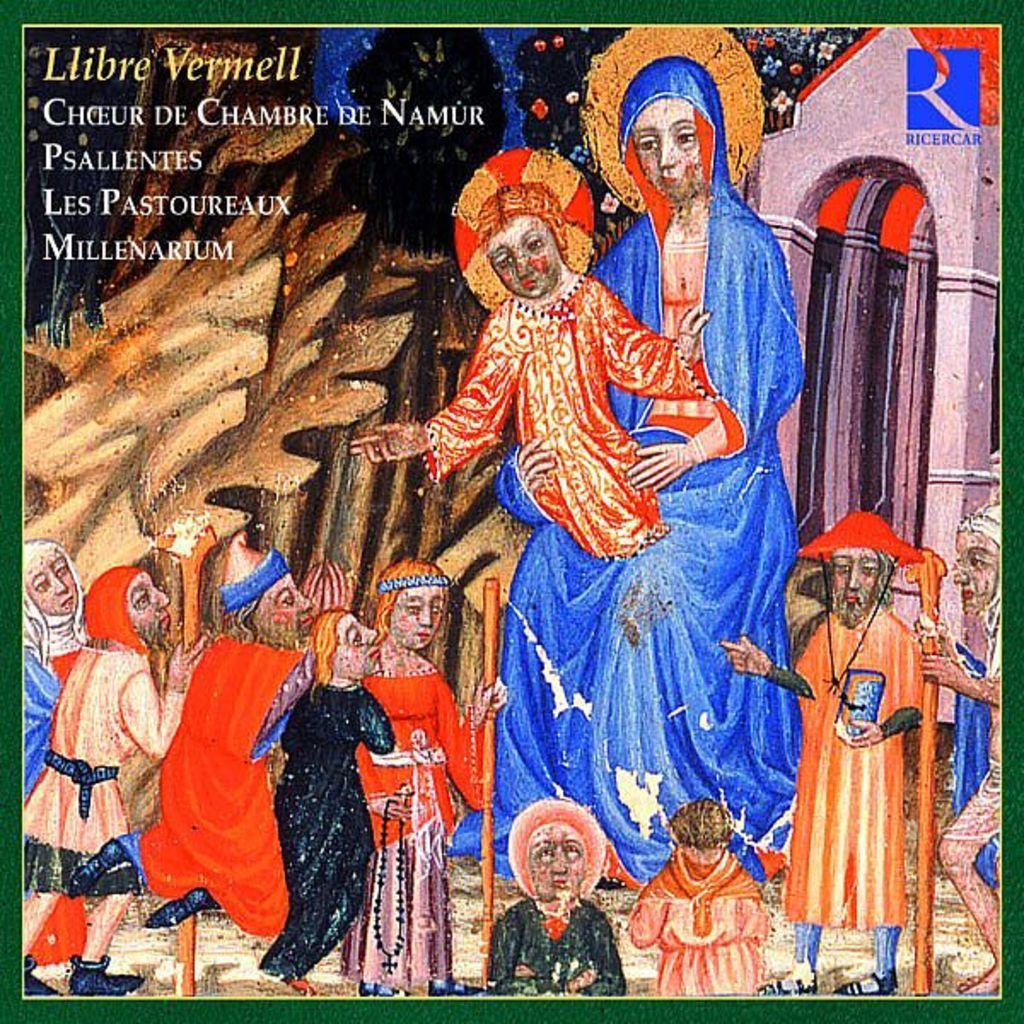Could you give a brief overview of what you see in this image? Here, we can see a picture, in that picture there are some people standing. 